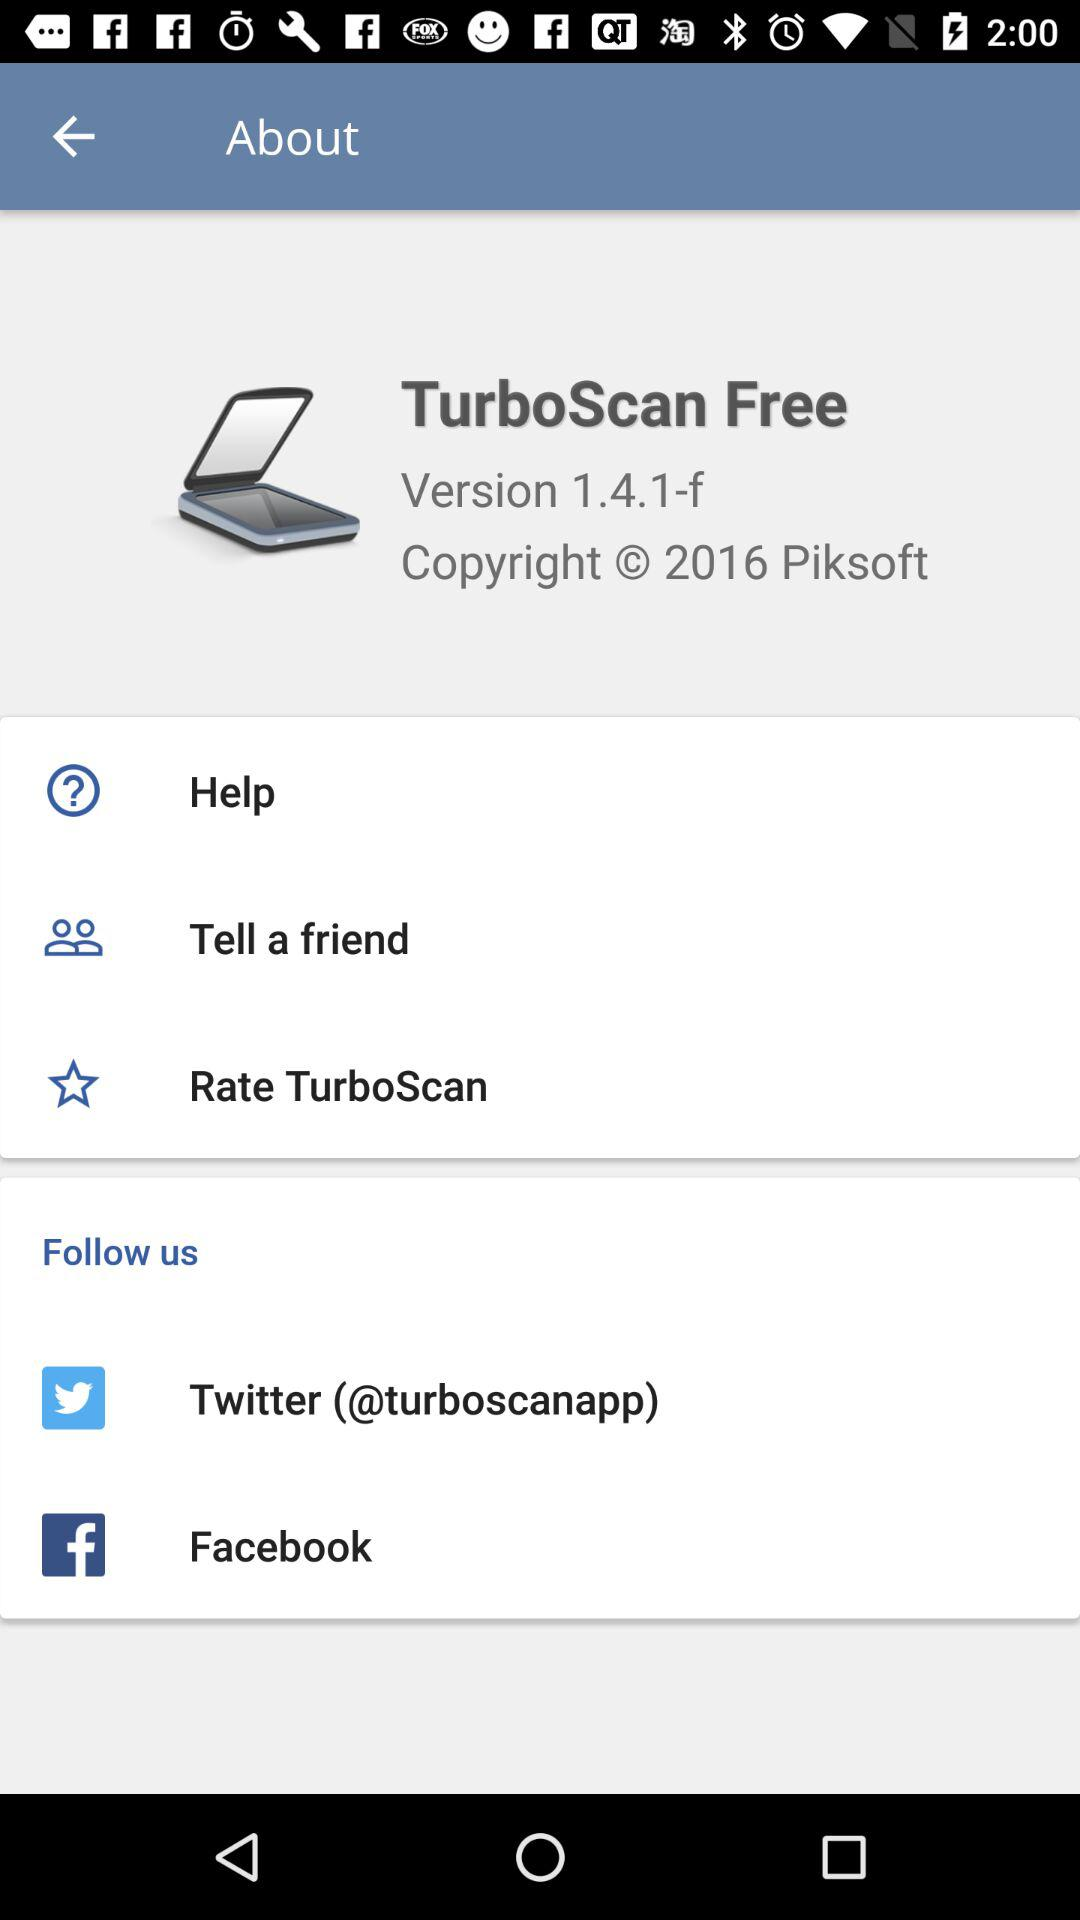Which are the different options to follow "TurboScan Free"? The different options to follow "TurboScan Free" are "Twitter" and "Facebook". 